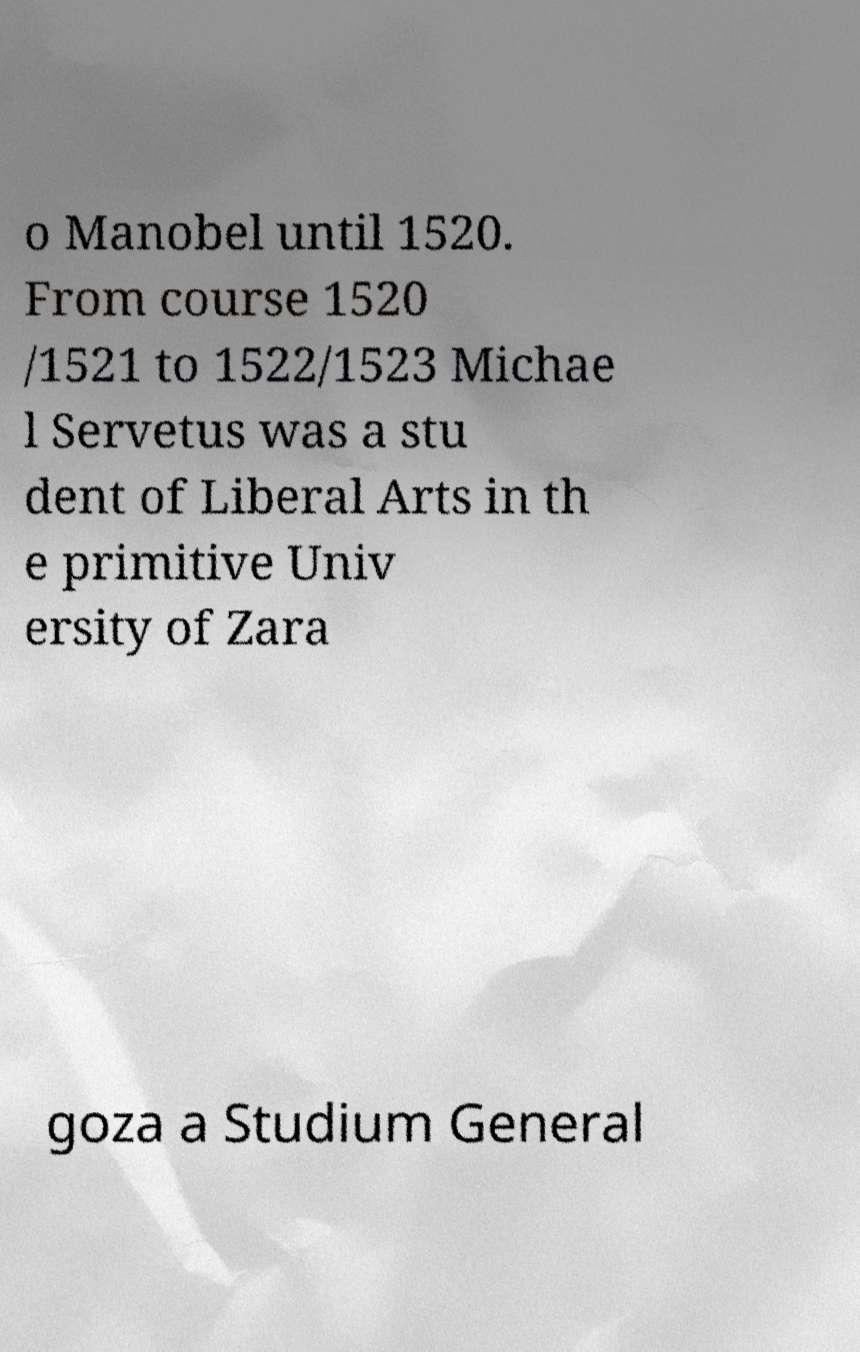What messages or text are displayed in this image? I need them in a readable, typed format. o Manobel until 1520. From course 1520 /1521 to 1522/1523 Michae l Servetus was a stu dent of Liberal Arts in th e primitive Univ ersity of Zara goza a Studium General 